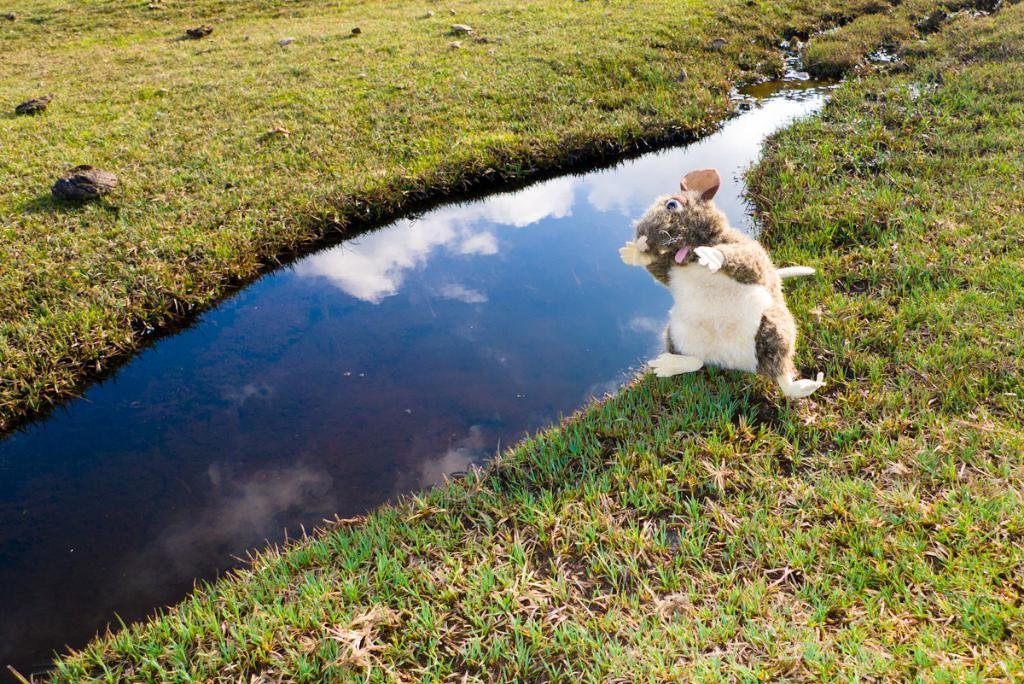What is the main subject in the foreground of the image? There is a dog in the foreground of the image. What type of terrain is visible in the image? There is grass in the image. What body of water can be seen in the image? There is a small pond in the image. What type of sponge is floating in the pond in the image? There is no sponge present in the image; it only features a dog, grass, and a small pond. 